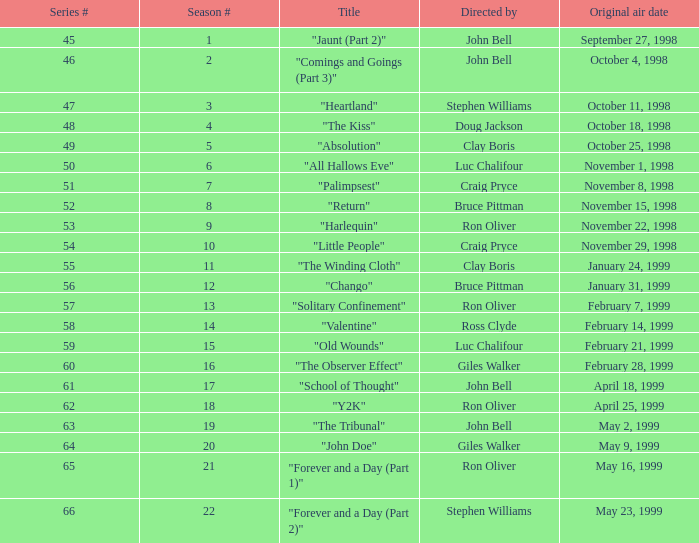Which initial broadcast date has a season number less than 21, and a title named "palimpsest"? November 8, 1998. 